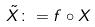Convert formula to latex. <formula><loc_0><loc_0><loc_500><loc_500>\tilde { X } \colon = f \circ X</formula> 